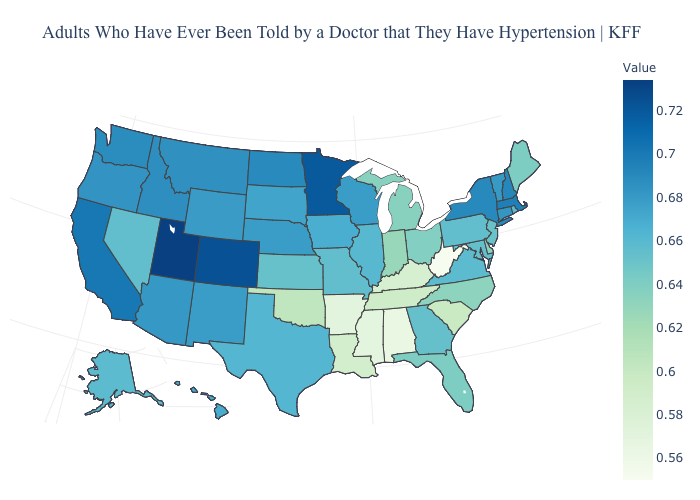Does Minnesota have the highest value in the MidWest?
Write a very short answer. Yes. Does North Dakota have the highest value in the USA?
Answer briefly. No. Among the states that border New Jersey , does Delaware have the lowest value?
Give a very brief answer. Yes. Does New Jersey have the lowest value in the Northeast?
Concise answer only. No. Among the states that border Rhode Island , does Massachusetts have the lowest value?
Keep it brief. No. Among the states that border Arizona , does Nevada have the lowest value?
Concise answer only. Yes. Does the map have missing data?
Write a very short answer. No. Among the states that border Wyoming , does South Dakota have the lowest value?
Concise answer only. Yes. 